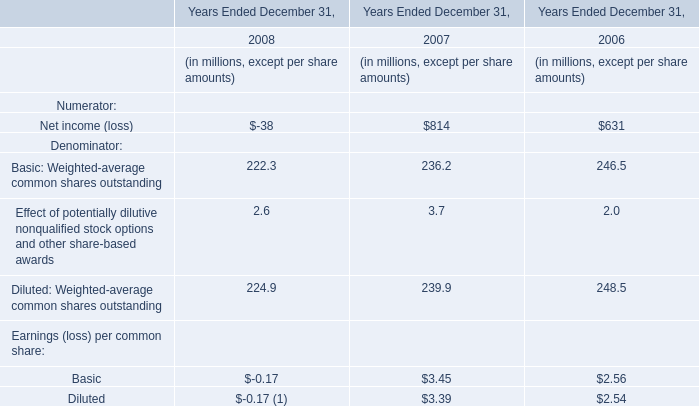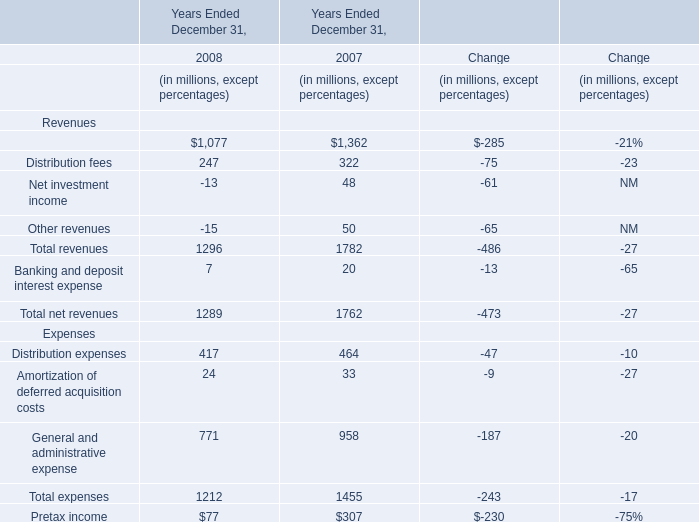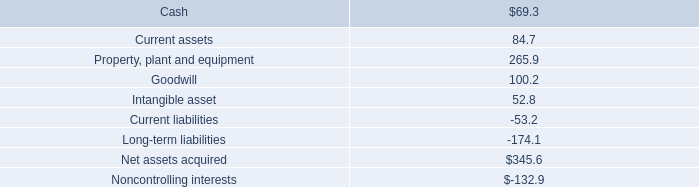What's the total amount of revenues excluding distribution fees and net investment income in 2008? (in millions) 
Computations: ((1296 - 247) - -13)
Answer: 1062.0. 